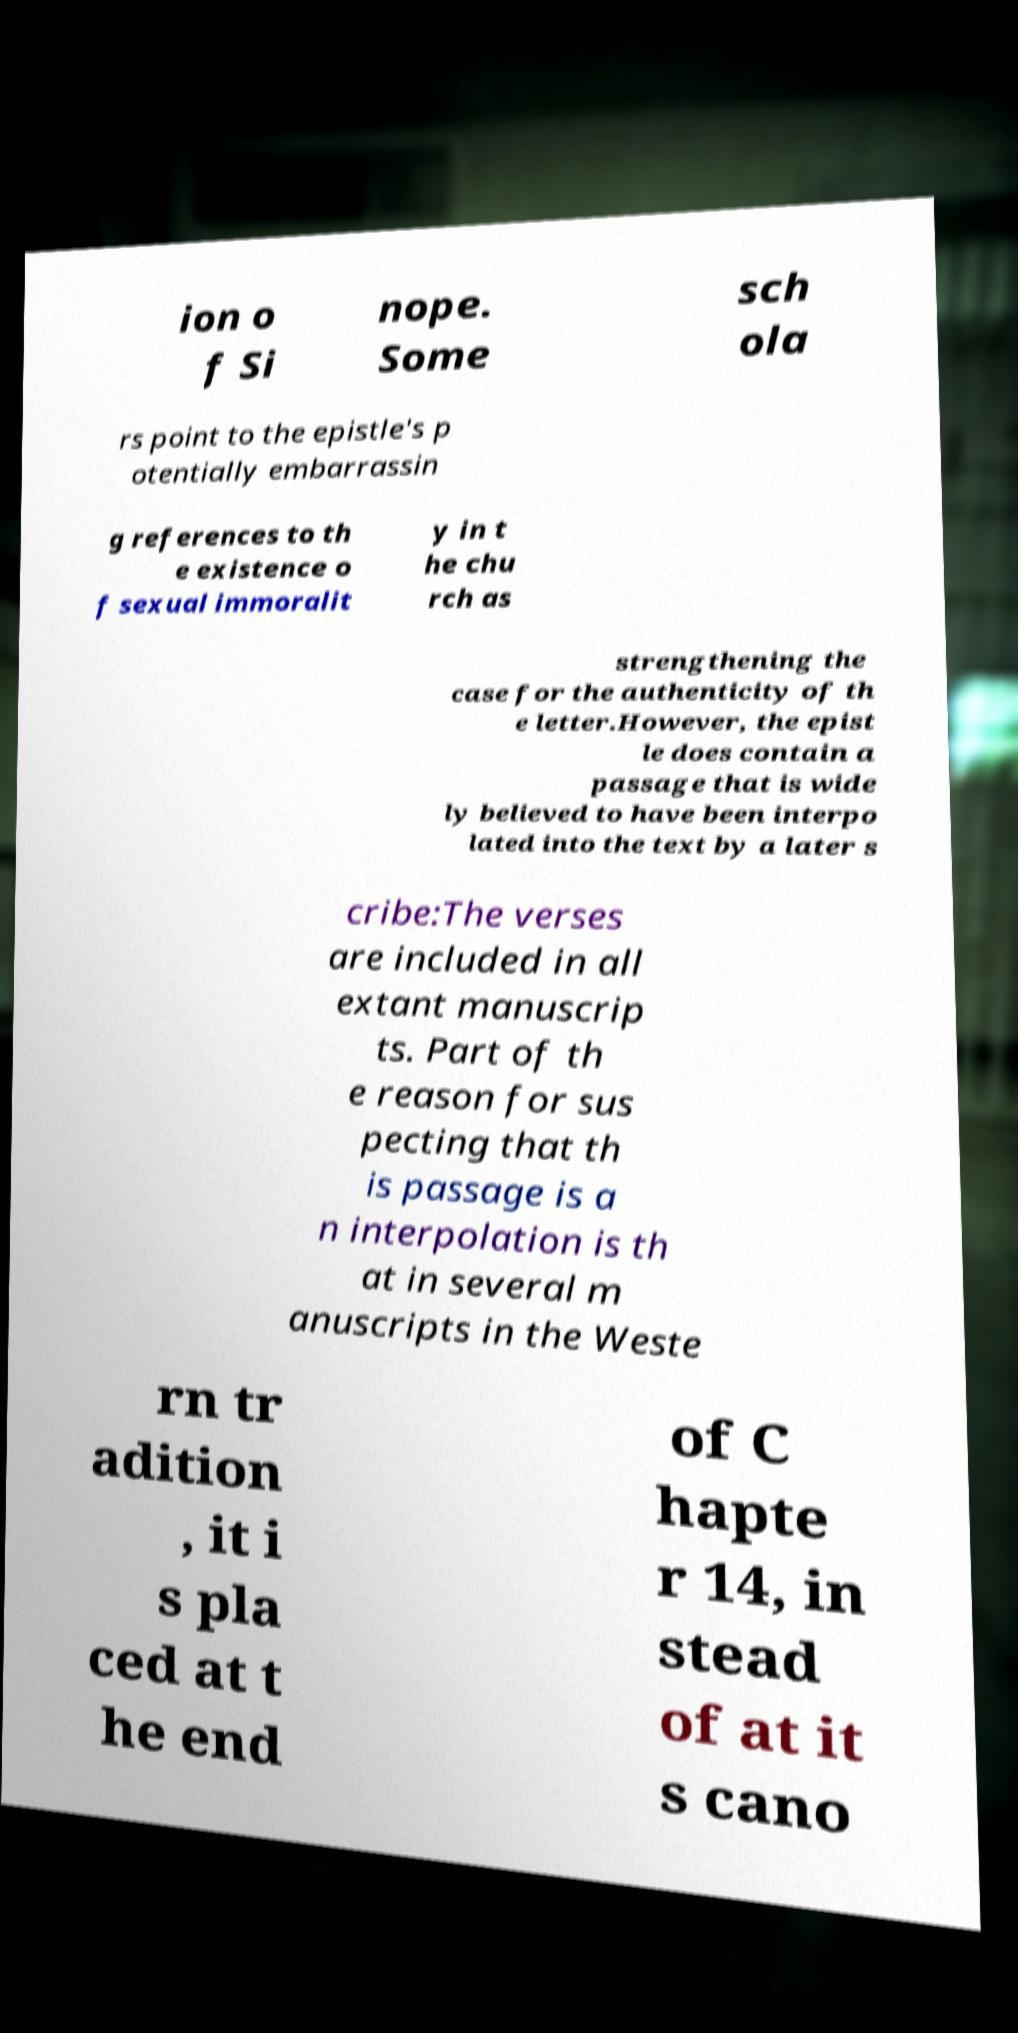I need the written content from this picture converted into text. Can you do that? ion o f Si nope. Some sch ola rs point to the epistle's p otentially embarrassin g references to th e existence o f sexual immoralit y in t he chu rch as strengthening the case for the authenticity of th e letter.However, the epist le does contain a passage that is wide ly believed to have been interpo lated into the text by a later s cribe:The verses are included in all extant manuscrip ts. Part of th e reason for sus pecting that th is passage is a n interpolation is th at in several m anuscripts in the Weste rn tr adition , it i s pla ced at t he end of C hapte r 14, in stead of at it s cano 